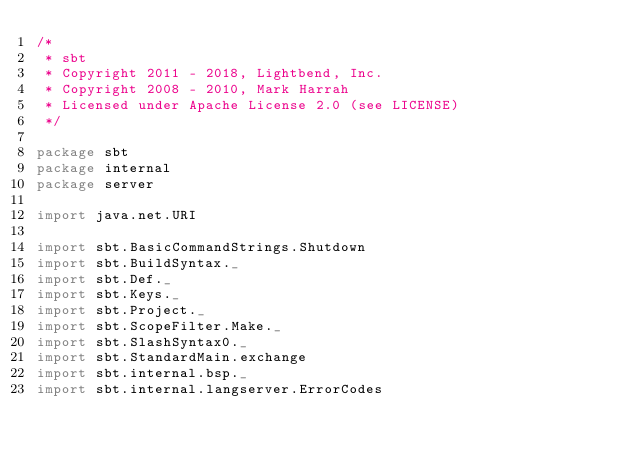<code> <loc_0><loc_0><loc_500><loc_500><_Scala_>/*
 * sbt
 * Copyright 2011 - 2018, Lightbend, Inc.
 * Copyright 2008 - 2010, Mark Harrah
 * Licensed under Apache License 2.0 (see LICENSE)
 */

package sbt
package internal
package server

import java.net.URI

import sbt.BasicCommandStrings.Shutdown
import sbt.BuildSyntax._
import sbt.Def._
import sbt.Keys._
import sbt.Project._
import sbt.ScopeFilter.Make._
import sbt.SlashSyntax0._
import sbt.StandardMain.exchange
import sbt.internal.bsp._
import sbt.internal.langserver.ErrorCodes</code> 